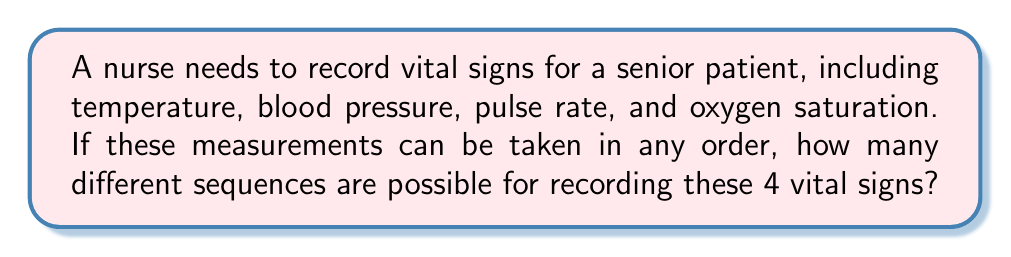Can you answer this question? Let's approach this step-by-step:

1) We have 4 distinct vital signs that need to be measured:
   - Temperature
   - Blood pressure
   - Pulse rate
   - Oxygen saturation

2) The order in which these measurements are taken can vary, and we need to find the number of possible sequences.

3) This is a permutation problem. We are arranging all 4 items in different orders, and each item is used exactly once.

4) The formula for permutations of n distinct objects is:

   $$ P(n) = n! $$

   Where $n!$ represents the factorial of n.

5) In this case, $n = 4$, so we need to calculate $4!$

6) Let's expand this:

   $$ 4! = 4 \times 3 \times 2 \times 1 = 24 $$

Therefore, there are 24 different possible sequences for recording these 4 vital signs.
Answer: 24 